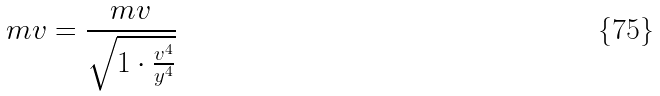<formula> <loc_0><loc_0><loc_500><loc_500>m v = \frac { m v } { \sqrt { 1 \cdot \frac { v ^ { 4 } } { y ^ { 4 } } } }</formula> 